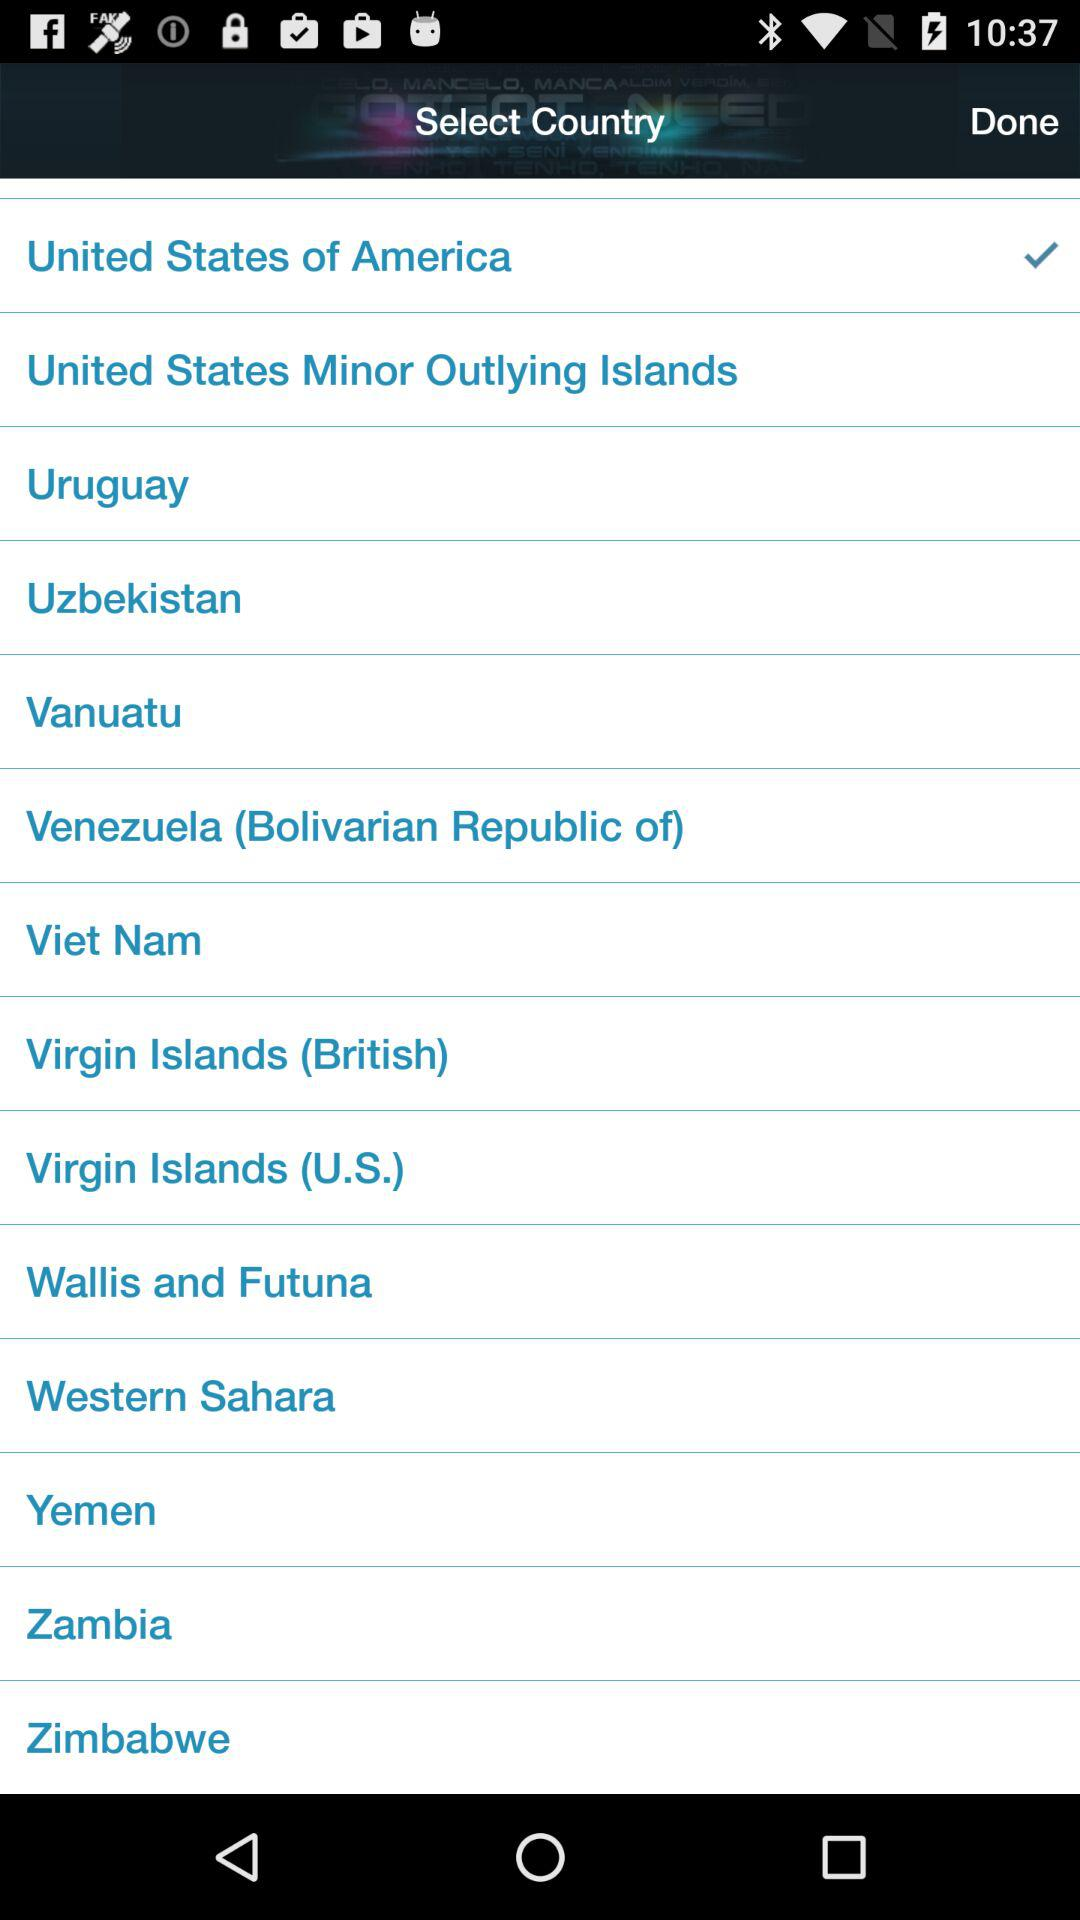Which country is selected? The selected country is the United States of America. 